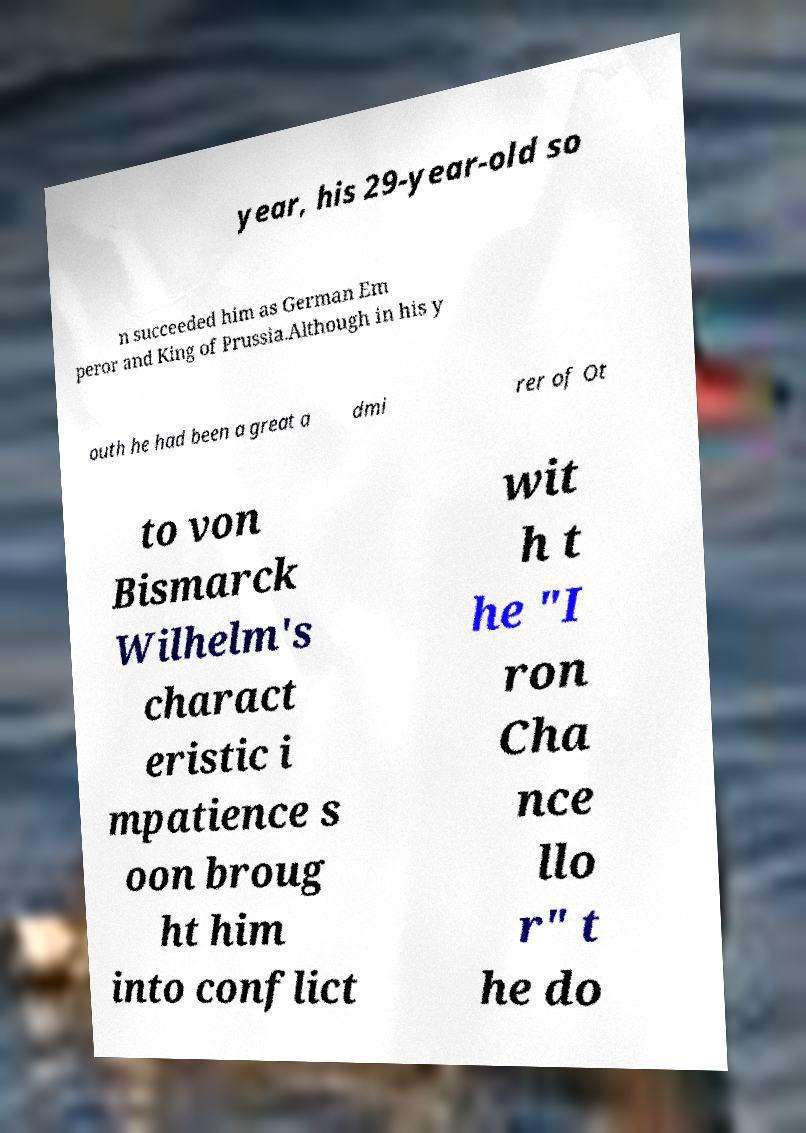What messages or text are displayed in this image? I need them in a readable, typed format. year, his 29-year-old so n succeeded him as German Em peror and King of Prussia.Although in his y outh he had been a great a dmi rer of Ot to von Bismarck Wilhelm's charact eristic i mpatience s oon broug ht him into conflict wit h t he "I ron Cha nce llo r" t he do 